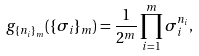Convert formula to latex. <formula><loc_0><loc_0><loc_500><loc_500>g _ { \{ n _ { i } \} _ { m } } ( \{ \sigma _ { i } \} _ { m } ) = \frac { 1 } { 2 ^ { m } } \prod _ { i = 1 } ^ { m } \sigma _ { i } ^ { n _ { i } } ,</formula> 